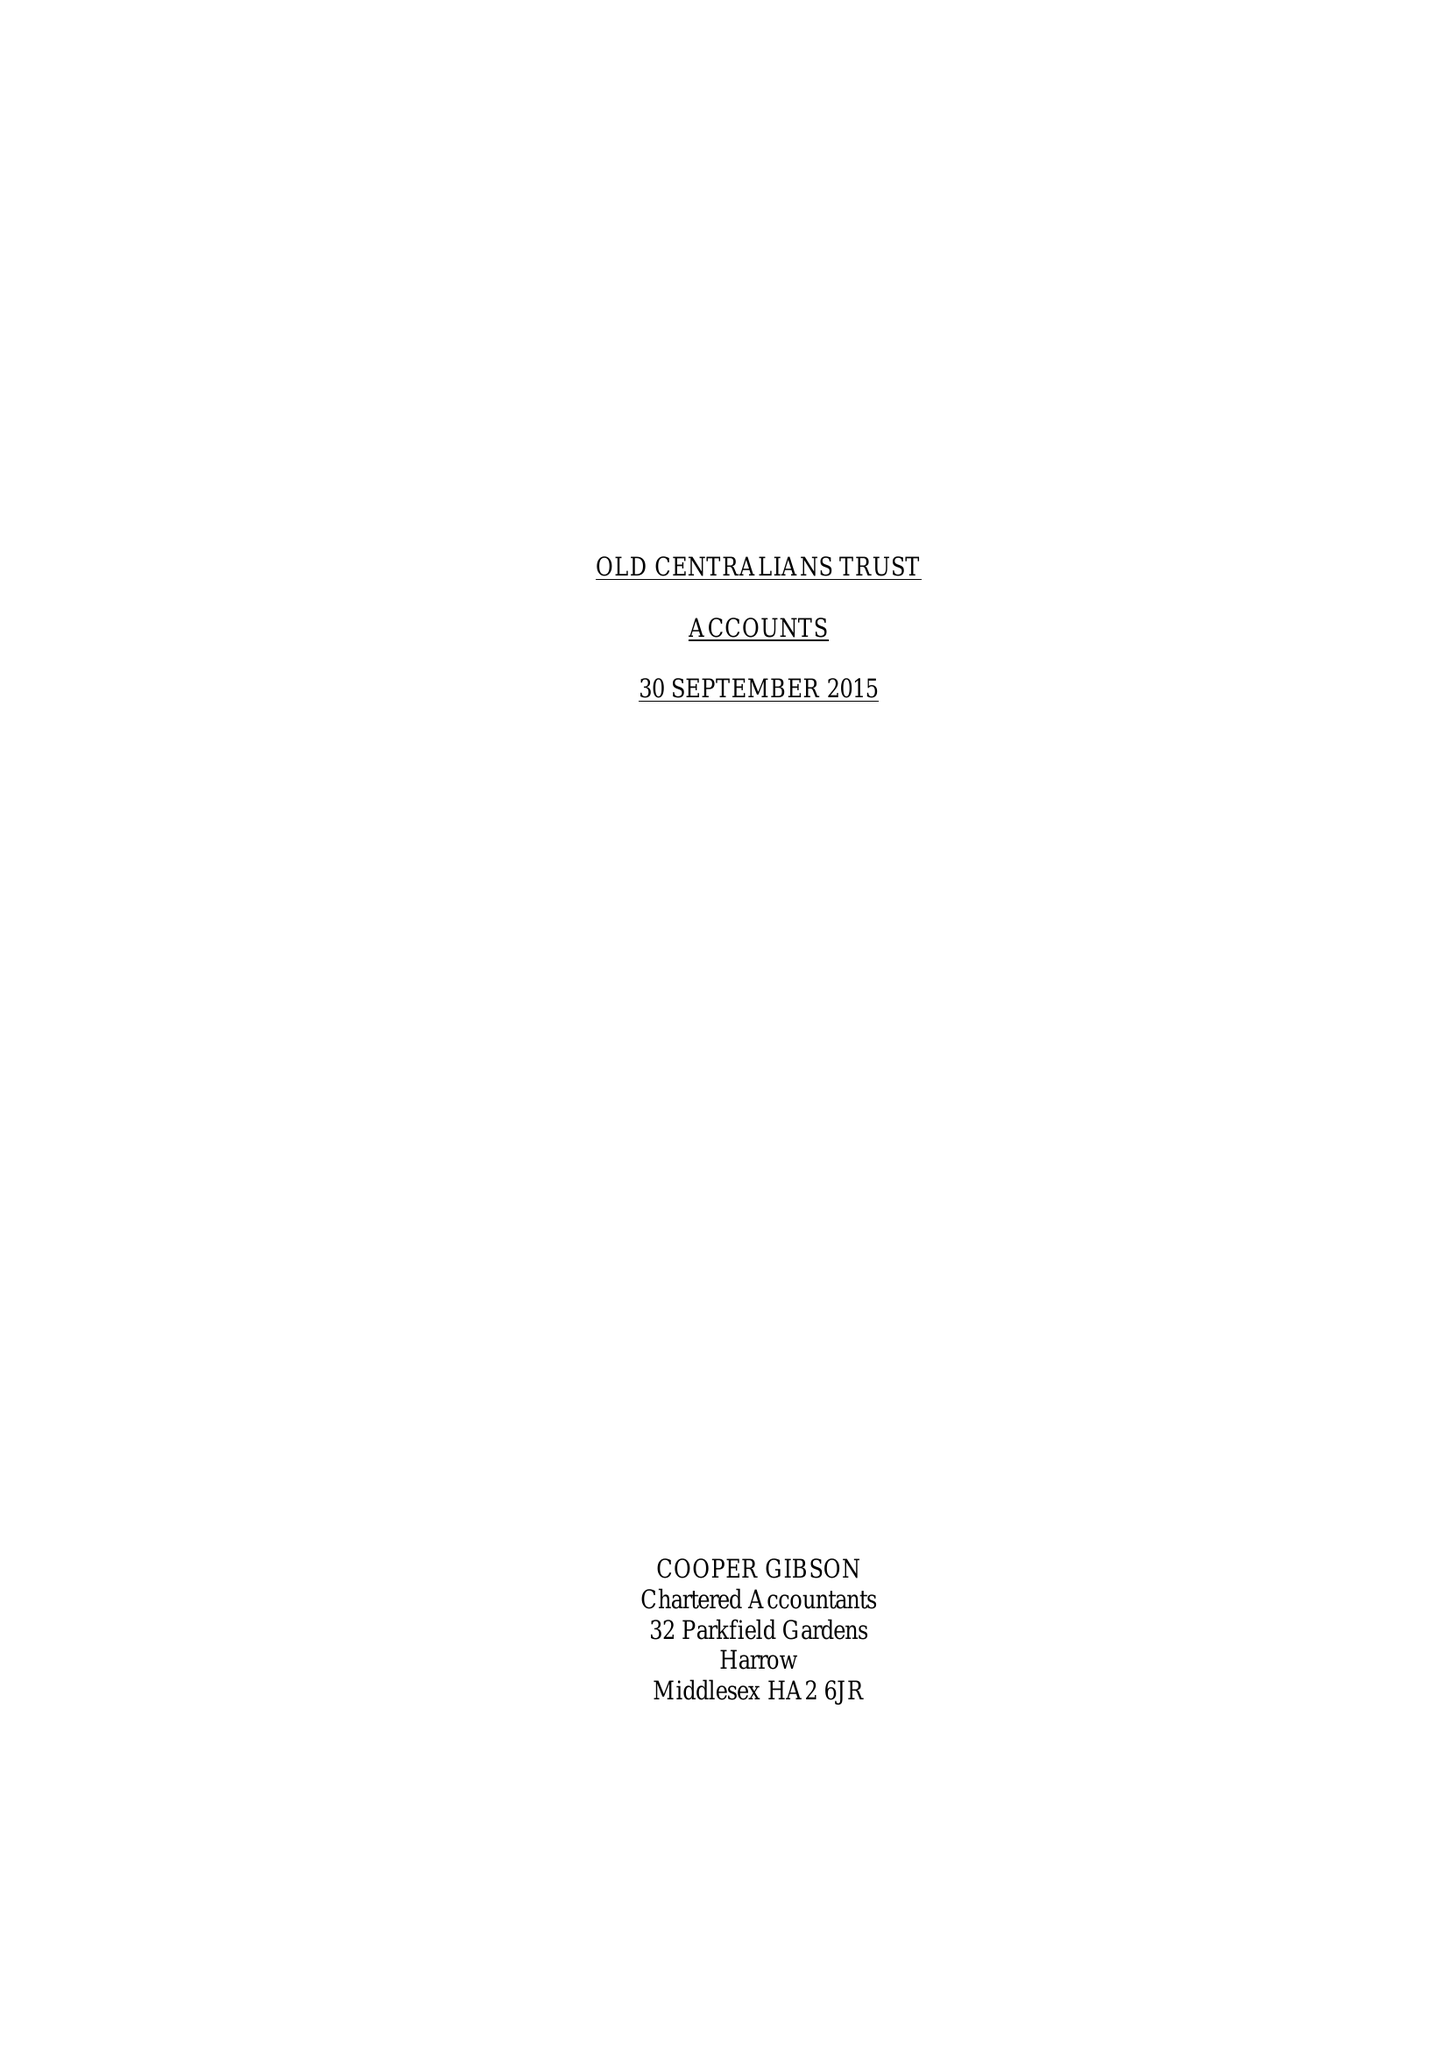What is the value for the address__street_line?
Answer the question using a single word or phrase. None 